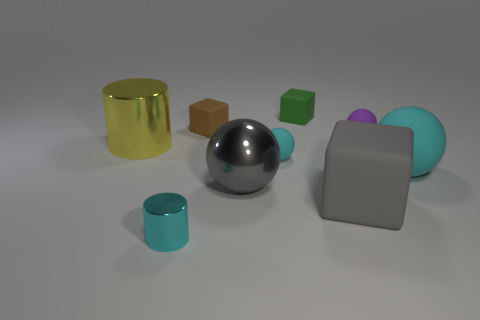Subtract all gray spheres. Subtract all brown blocks. How many spheres are left? 3 Add 1 small red spheres. How many objects exist? 10 Subtract all cylinders. How many objects are left? 7 Add 2 tiny green blocks. How many tiny green blocks are left? 3 Add 9 matte cylinders. How many matte cylinders exist? 9 Subtract 1 cyan balls. How many objects are left? 8 Subtract all purple rubber balls. Subtract all small green rubber blocks. How many objects are left? 7 